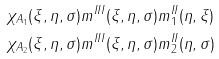Convert formula to latex. <formula><loc_0><loc_0><loc_500><loc_500>& \chi _ { A _ { 1 } } ( \xi , \eta , \sigma ) m ^ { I I I } ( \xi , \eta , \sigma ) m ^ { I I } _ { 1 } ( \eta , \xi ) \\ & \chi _ { A _ { 2 } } ( \xi , \eta , \sigma ) m ^ { I I I } ( \xi , \eta , \sigma ) m ^ { I I } _ { 2 } ( \eta , \sigma ) \\</formula> 